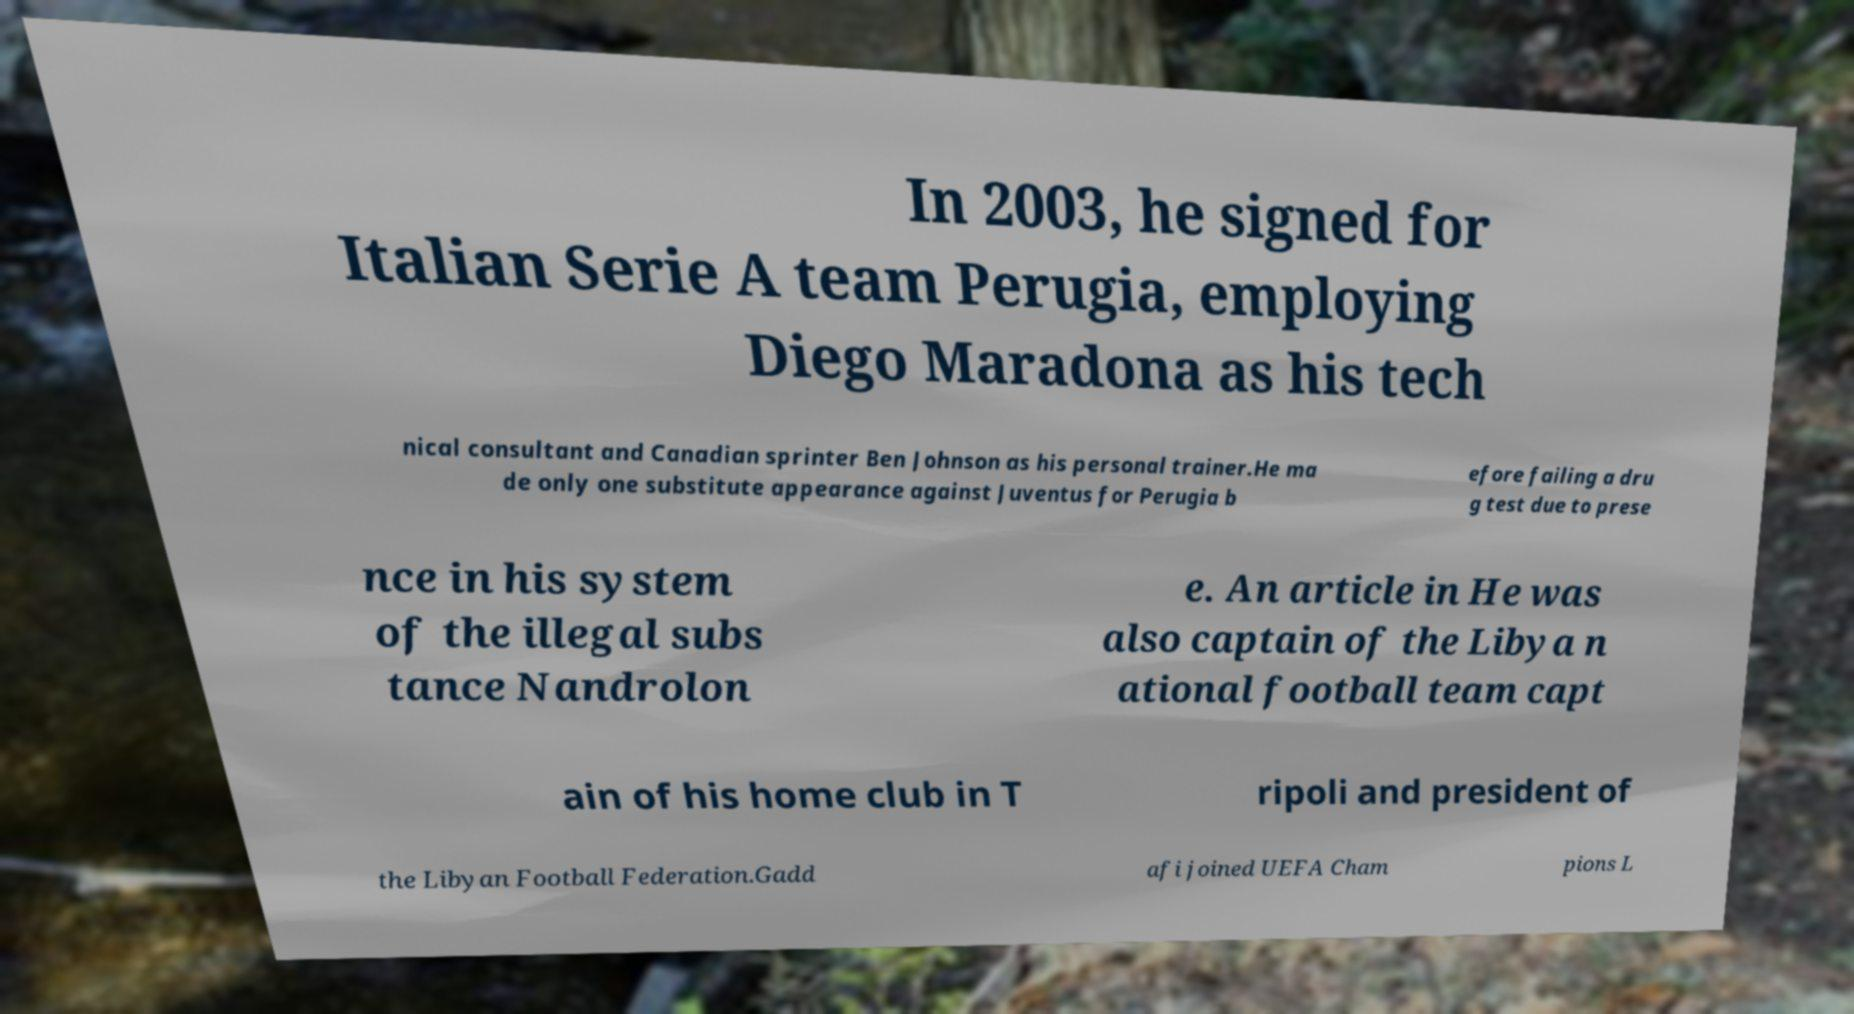I need the written content from this picture converted into text. Can you do that? In 2003, he signed for Italian Serie A team Perugia, employing Diego Maradona as his tech nical consultant and Canadian sprinter Ben Johnson as his personal trainer.He ma de only one substitute appearance against Juventus for Perugia b efore failing a dru g test due to prese nce in his system of the illegal subs tance Nandrolon e. An article in He was also captain of the Libya n ational football team capt ain of his home club in T ripoli and president of the Libyan Football Federation.Gadd afi joined UEFA Cham pions L 